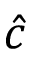<formula> <loc_0><loc_0><loc_500><loc_500>\hat { c }</formula> 